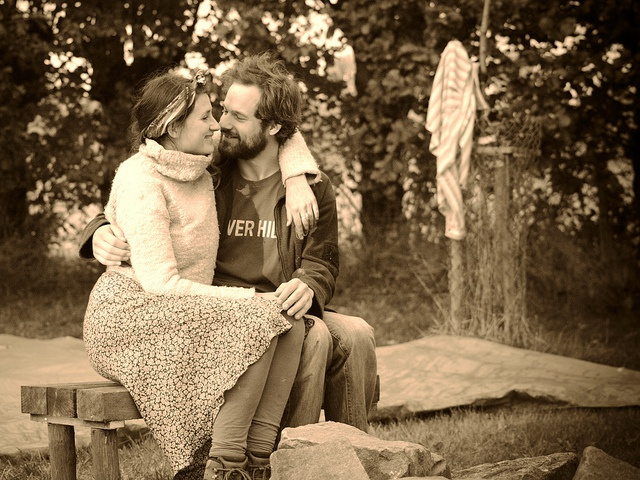Describe the objects in this image and their specific colors. I can see people in gray, tan, and lightyellow tones, people in gray, black, tan, and maroon tones, and bench in gray and tan tones in this image. 